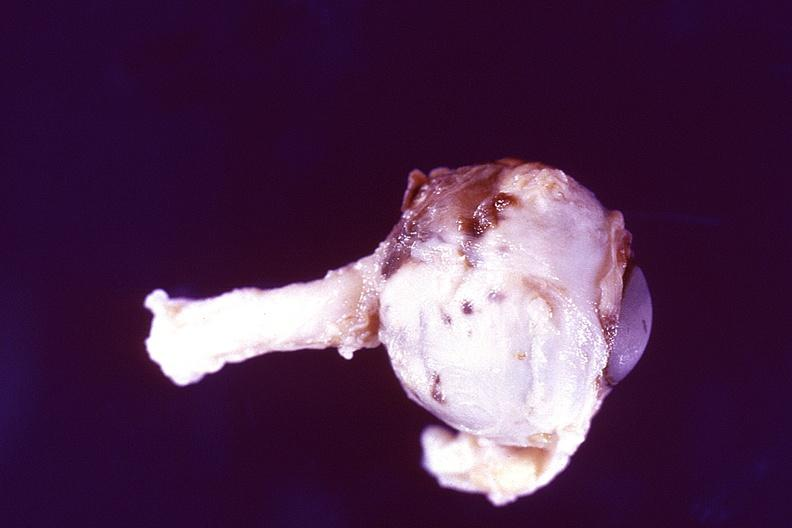does child show disseminated intravascular coagulation dic?
Answer the question using a single word or phrase. No 